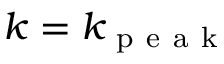Convert formula to latex. <formula><loc_0><loc_0><loc_500><loc_500>k = k _ { p e a k }</formula> 